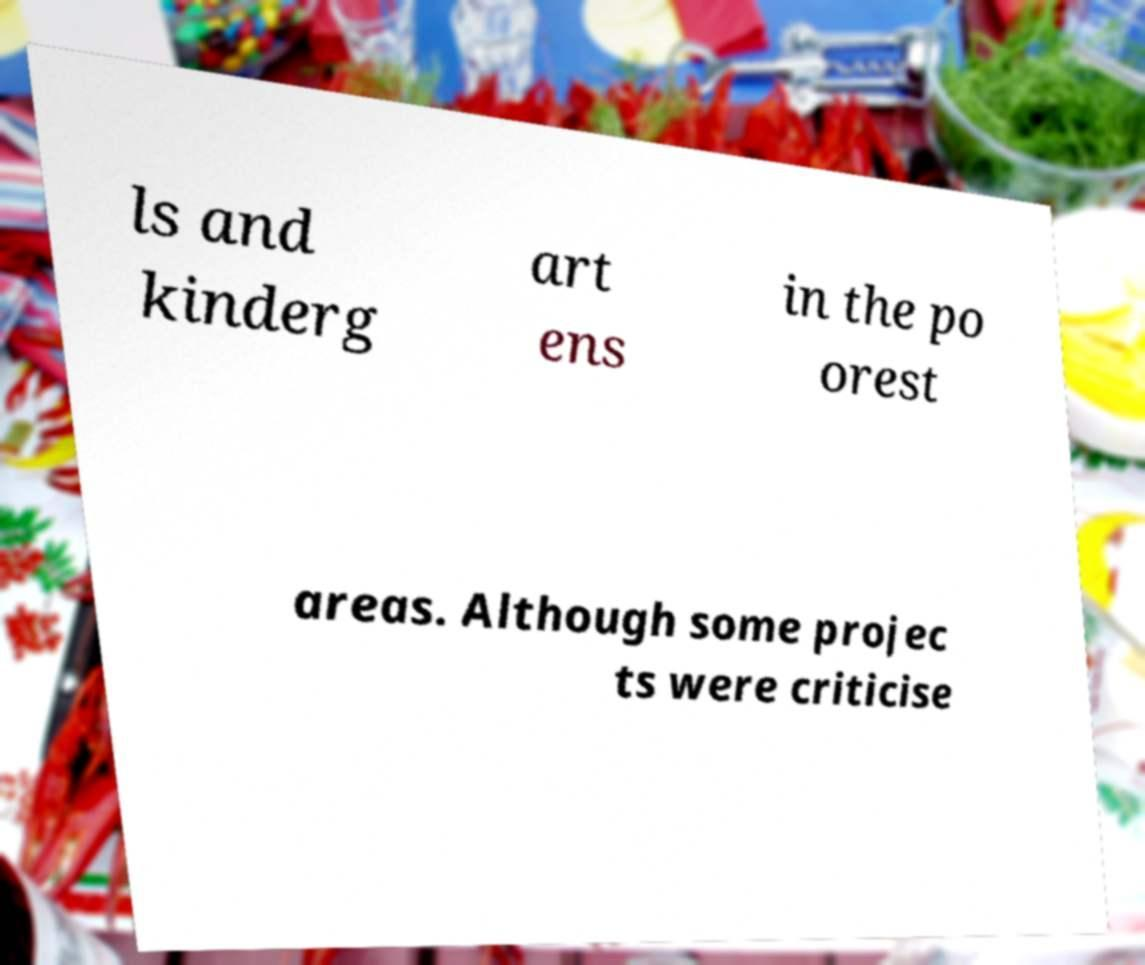There's text embedded in this image that I need extracted. Can you transcribe it verbatim? ls and kinderg art ens in the po orest areas. Although some projec ts were criticise 